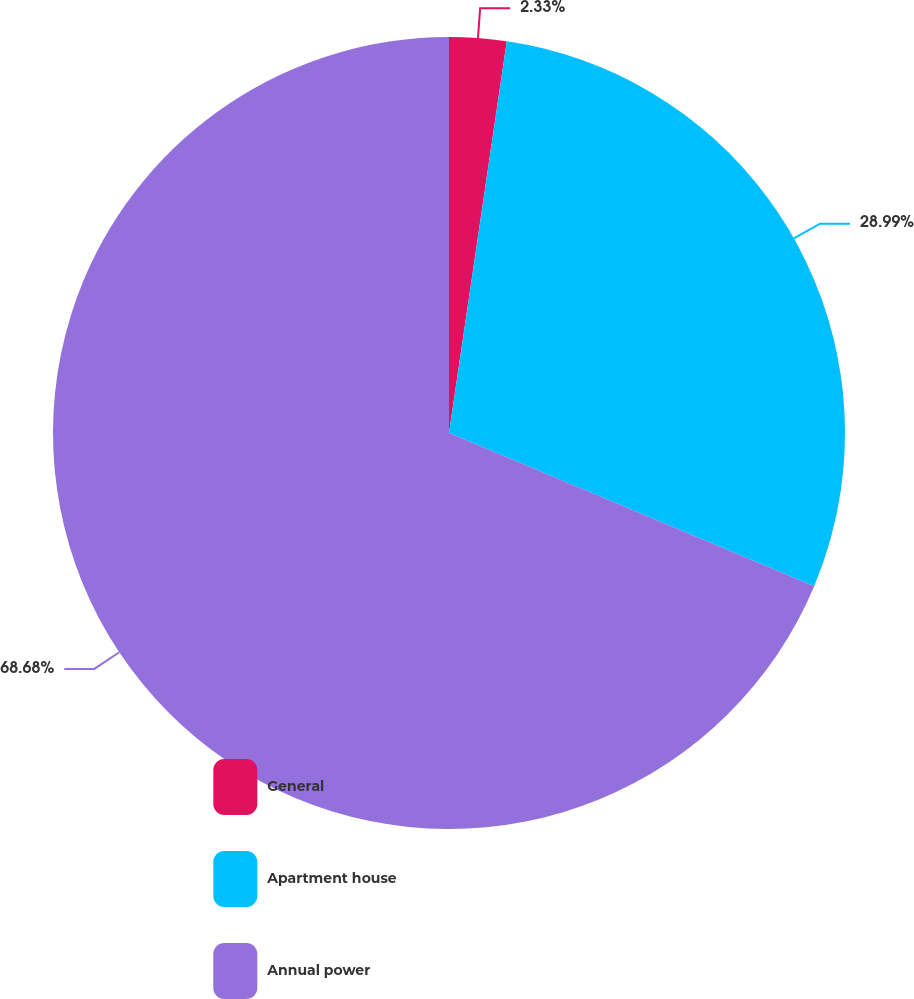Convert chart to OTSL. <chart><loc_0><loc_0><loc_500><loc_500><pie_chart><fcel>General<fcel>Apartment house<fcel>Annual power<nl><fcel>2.33%<fcel>28.99%<fcel>68.68%<nl></chart> 